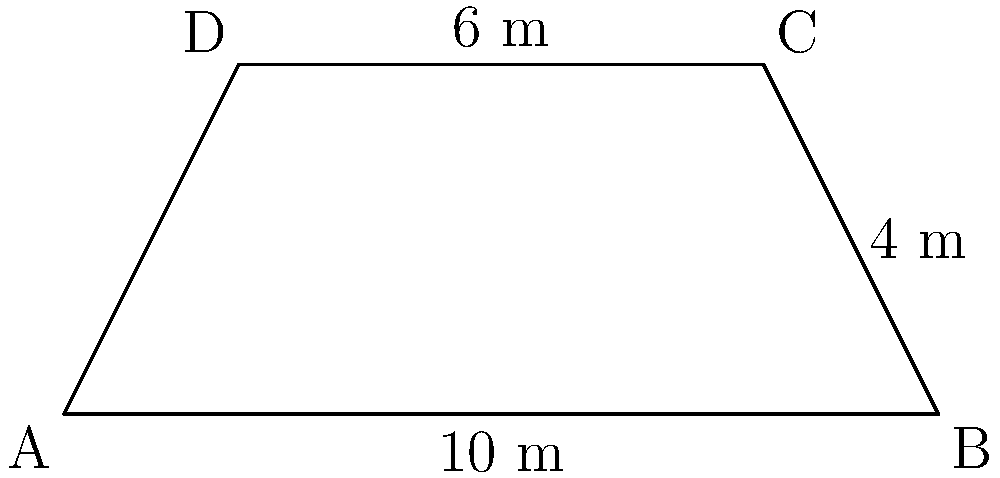A new branch location for your insurance agency is planned on a trapezoid-shaped plot of land. The parallel sides of the trapezoid measure 10 meters and 6 meters, while the height of the trapezoid is 4 meters. Calculate the total area of the plot in square meters to determine if it meets the minimum space requirements for the new branch. To find the area of a trapezoid, we can use the formula:

$$A = \frac{1}{2}(b_1 + b_2)h$$

Where:
$A$ = Area of the trapezoid
$b_1$ and $b_2$ = Lengths of the parallel sides
$h$ = Height of the trapezoid

Given:
$b_1 = 10$ meters
$b_2 = 6$ meters
$h = 4$ meters

Let's substitute these values into the formula:

$$A = \frac{1}{2}(10 + 6) \times 4$$

$$A = \frac{1}{2}(16) \times 4$$

$$A = 8 \times 4$$

$$A = 32$$

Therefore, the total area of the trapezoid-shaped plot is 32 square meters.
Answer: 32 square meters 